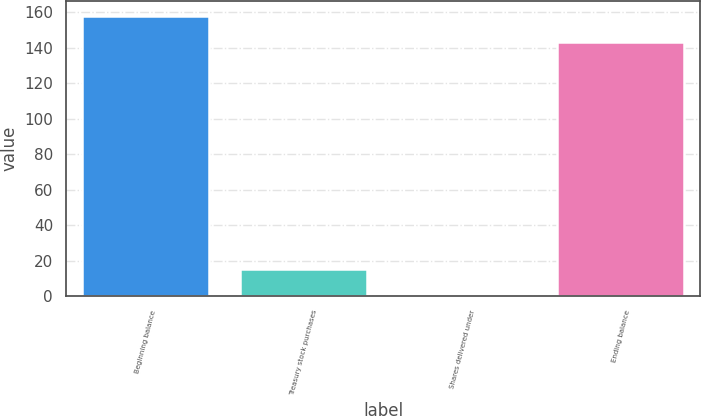<chart> <loc_0><loc_0><loc_500><loc_500><bar_chart><fcel>Beginning balance<fcel>Treasury stock purchases<fcel>Shares delivered under<fcel>Ending balance<nl><fcel>158.09<fcel>15.39<fcel>0.5<fcel>143.2<nl></chart> 